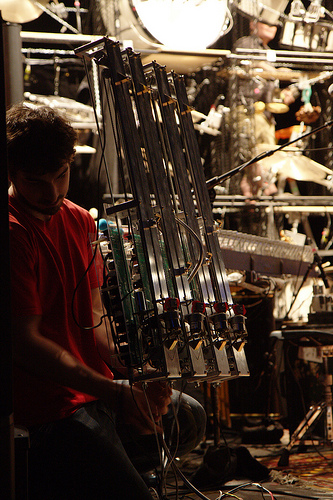<image>
Can you confirm if the contraption is behind the man? No. The contraption is not behind the man. From this viewpoint, the contraption appears to be positioned elsewhere in the scene. 